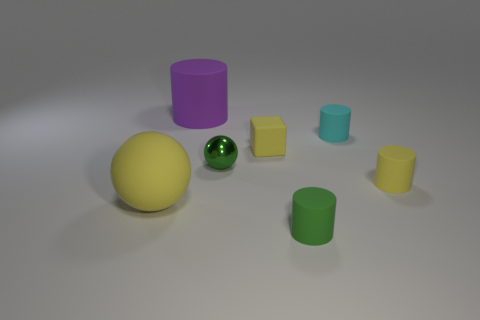Subtract all small green cylinders. How many cylinders are left? 3 Subtract all purple cylinders. How many cylinders are left? 3 Add 2 green shiny blocks. How many objects exist? 9 Subtract all brown cylinders. Subtract all red blocks. How many cylinders are left? 4 Subtract all cubes. How many objects are left? 6 Add 5 large purple objects. How many large purple objects are left? 6 Add 4 yellow metal spheres. How many yellow metal spheres exist? 4 Subtract 1 green cylinders. How many objects are left? 6 Subtract all cylinders. Subtract all yellow spheres. How many objects are left? 2 